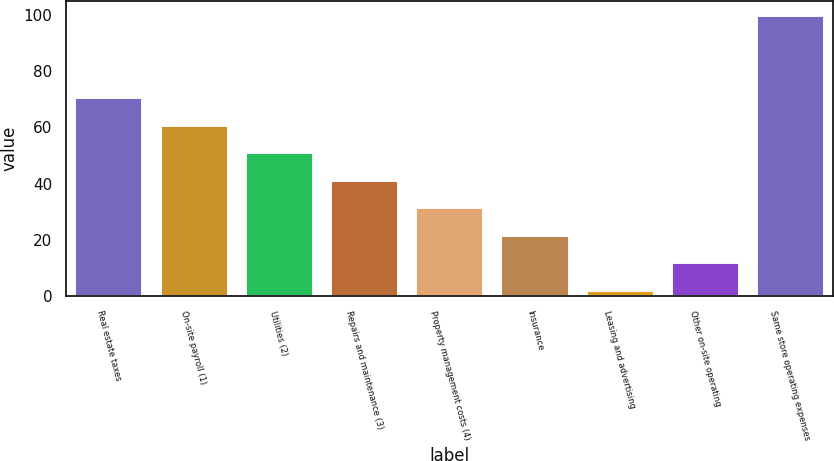Convert chart. <chart><loc_0><loc_0><loc_500><loc_500><bar_chart><fcel>Real estate taxes<fcel>On-site payroll (1)<fcel>Utilities (2)<fcel>Repairs and maintenance (3)<fcel>Property management costs (4)<fcel>Insurance<fcel>Leasing and advertising<fcel>Other on-site operating<fcel>Same store operating expenses<nl><fcel>70.72<fcel>60.96<fcel>51.2<fcel>41.44<fcel>31.68<fcel>21.92<fcel>2.4<fcel>12.16<fcel>100<nl></chart> 